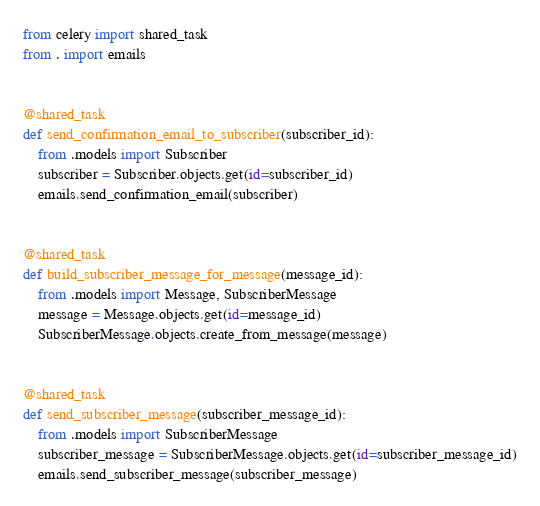<code> <loc_0><loc_0><loc_500><loc_500><_Python_>from celery import shared_task
from . import emails


@shared_task
def send_confirmation_email_to_subscriber(subscriber_id):
    from .models import Subscriber
    subscriber = Subscriber.objects.get(id=subscriber_id)
    emails.send_confirmation_email(subscriber)


@shared_task
def build_subscriber_message_for_message(message_id):
    from .models import Message, SubscriberMessage
    message = Message.objects.get(id=message_id)
    SubscriberMessage.objects.create_from_message(message)


@shared_task
def send_subscriber_message(subscriber_message_id):
    from .models import SubscriberMessage
    subscriber_message = SubscriberMessage.objects.get(id=subscriber_message_id)
    emails.send_subscriber_message(subscriber_message)
</code> 